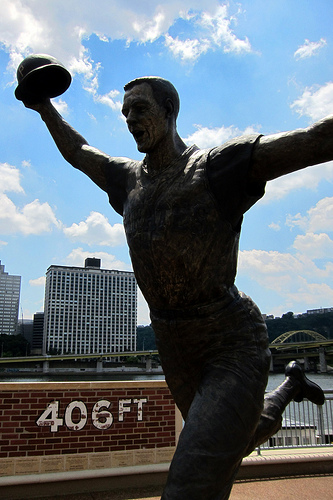<image>
Can you confirm if the sky is behind the building? Yes. From this viewpoint, the sky is positioned behind the building, with the building partially or fully occluding the sky. 